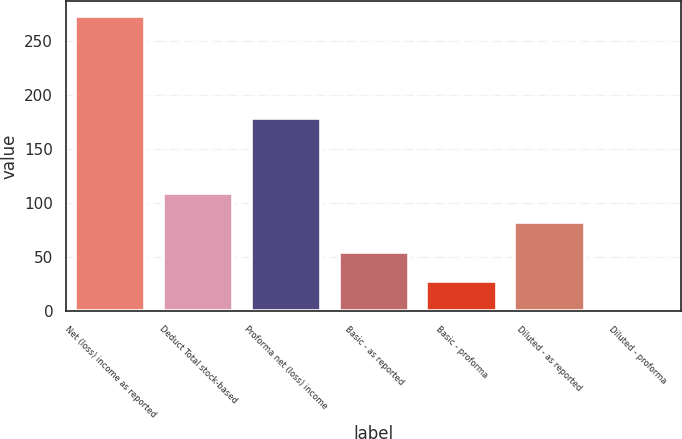Convert chart. <chart><loc_0><loc_0><loc_500><loc_500><bar_chart><fcel>Net (loss) income as reported<fcel>Deduct Total stock-based<fcel>Proforma net (loss) income<fcel>Basic - as reported<fcel>Basic - proforma<fcel>Diluted - as reported<fcel>Diluted - proforma<nl><fcel>273<fcel>109.41<fcel>179<fcel>54.87<fcel>27.6<fcel>82.14<fcel>0.33<nl></chart> 